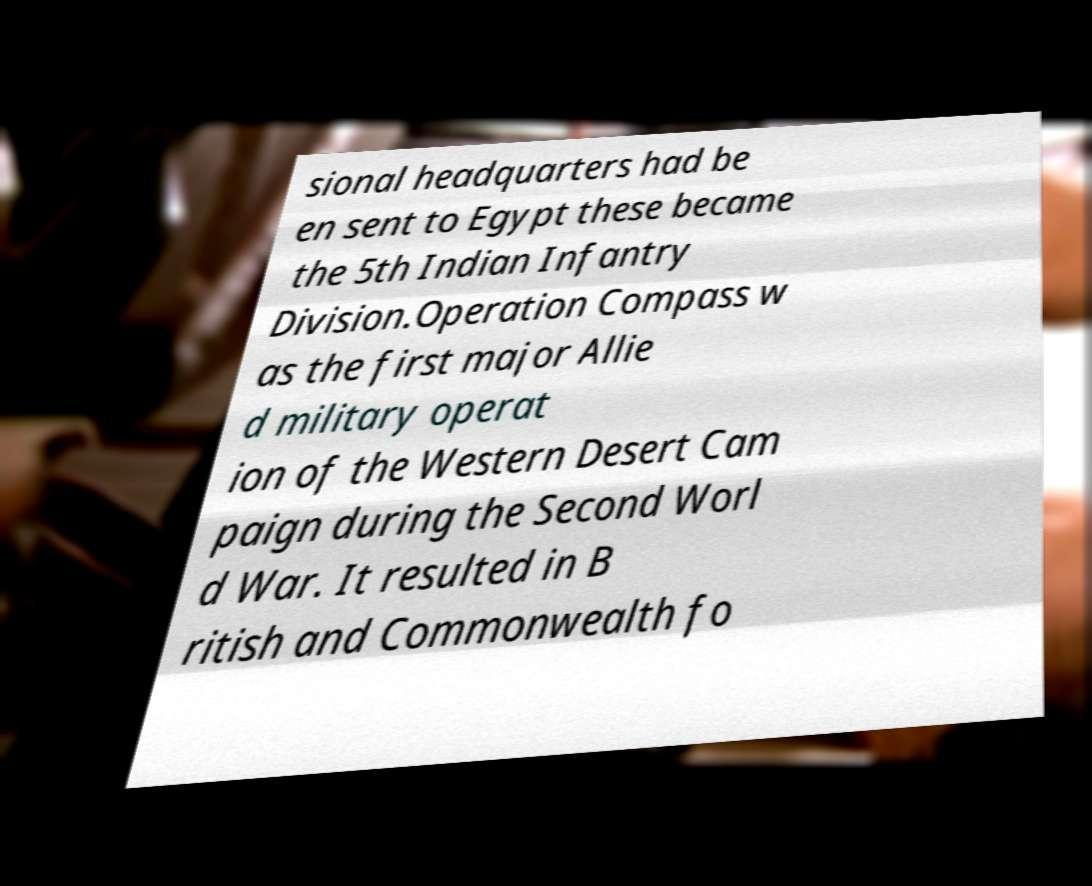What messages or text are displayed in this image? I need them in a readable, typed format. sional headquarters had be en sent to Egypt these became the 5th Indian Infantry Division.Operation Compass w as the first major Allie d military operat ion of the Western Desert Cam paign during the Second Worl d War. It resulted in B ritish and Commonwealth fo 